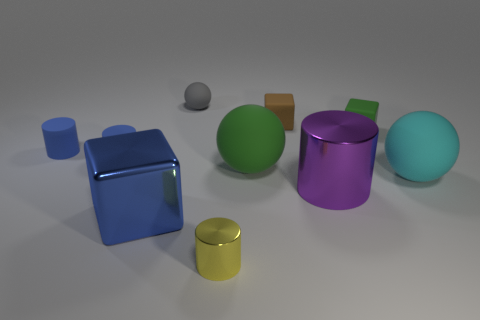What number of cyan objects are either small metal blocks or blocks?
Keep it short and to the point. 0. What is the material of the tiny cube left of the small green rubber block?
Your answer should be very brief. Rubber. How many big metal cylinders are to the left of the tiny thing that is to the right of the purple metallic cylinder?
Provide a short and direct response. 1. What number of other cyan rubber objects are the same shape as the big cyan matte object?
Offer a terse response. 0. What number of big green shiny spheres are there?
Your response must be concise. 0. There is a tiny rubber object behind the brown matte thing; what is its color?
Your answer should be very brief. Gray. There is a ball to the right of the brown object right of the small gray rubber object; what is its color?
Provide a succinct answer. Cyan. What color is the other ball that is the same size as the green matte sphere?
Give a very brief answer. Cyan. How many shiny things are both on the left side of the tiny yellow thing and in front of the shiny block?
Provide a succinct answer. 0. There is a block that is to the left of the tiny green matte thing and behind the big metal block; what material is it?
Give a very brief answer. Rubber. 